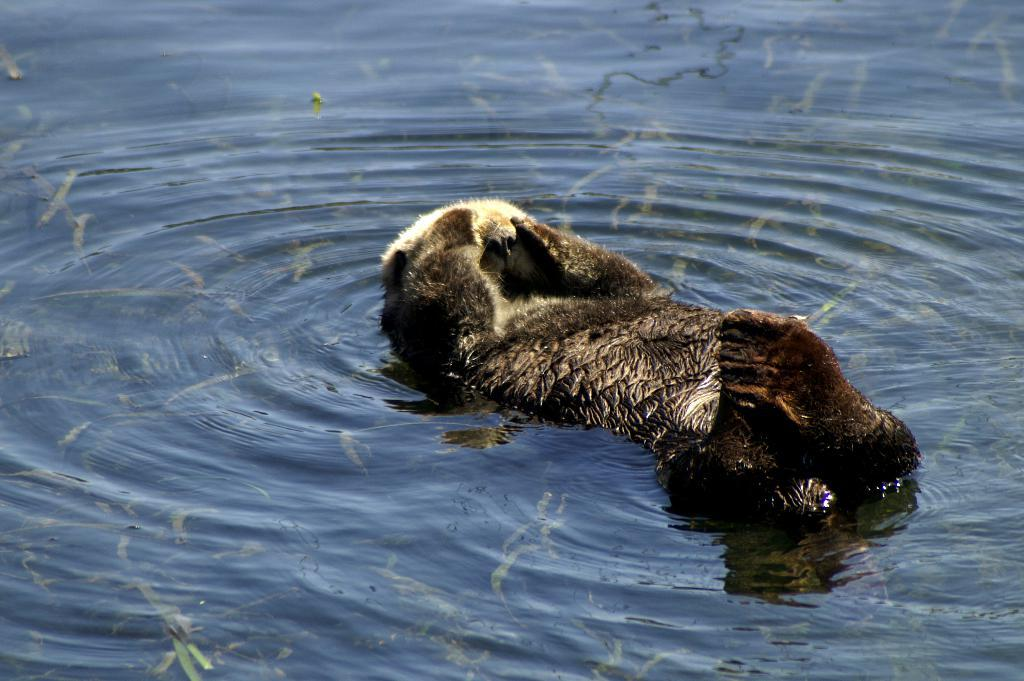What type of animal is in the image? There is a sea otter in the image. Where is the sea otter located? The sea otter is in the water. What can be seen in the water besides the sea otter? There are underwater plants visible in the image. What type of glue is the sea otter using to stick objects together in the image? There is no glue or objects being stuck together in the image; it simply features a sea otter in the water with underwater plants. 